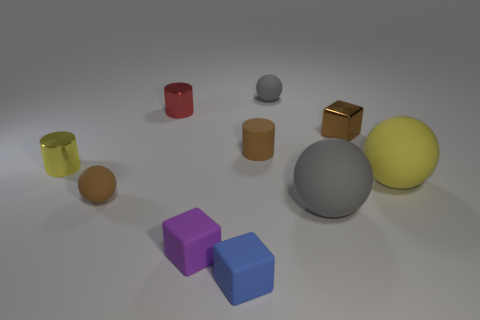Do the metal block and the matte sphere left of the blue rubber block have the same color?
Make the answer very short. Yes. Is there a tiny rubber cube that has the same color as the tiny matte cylinder?
Your response must be concise. No. Is the material of the purple thing the same as the brown thing that is to the right of the tiny gray sphere?
Your answer should be compact. No. What number of tiny objects are either purple blocks or red shiny objects?
Ensure brevity in your answer.  2. There is a small ball that is the same color as the shiny block; what material is it?
Offer a terse response. Rubber. Are there fewer green blocks than small metallic cylinders?
Your answer should be very brief. Yes. Does the rubber sphere right of the large gray thing have the same size as the rubber block in front of the purple matte thing?
Offer a very short reply. No. What number of brown objects are small matte balls or cylinders?
Provide a short and direct response. 2. There is a matte object that is the same color as the small matte cylinder; what size is it?
Your answer should be very brief. Small. Is the number of tiny rubber cubes greater than the number of things?
Your answer should be very brief. No. 